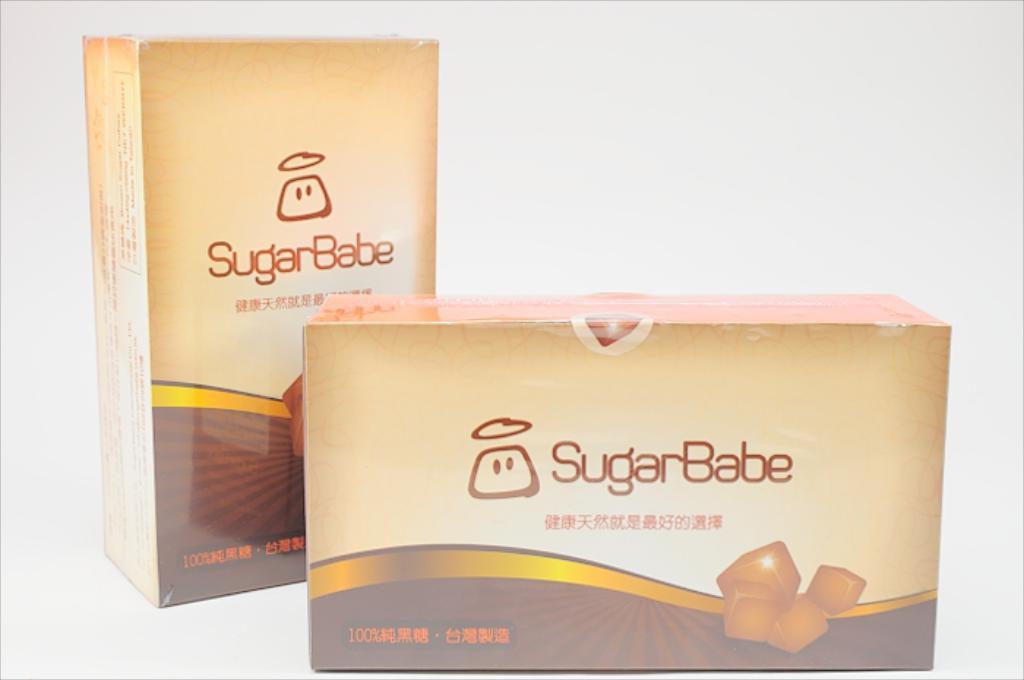What is the brand name of these boxes?
Make the answer very short. Sugarbabe. How many sugar babe are available in this image?
Your answer should be compact. 2. 